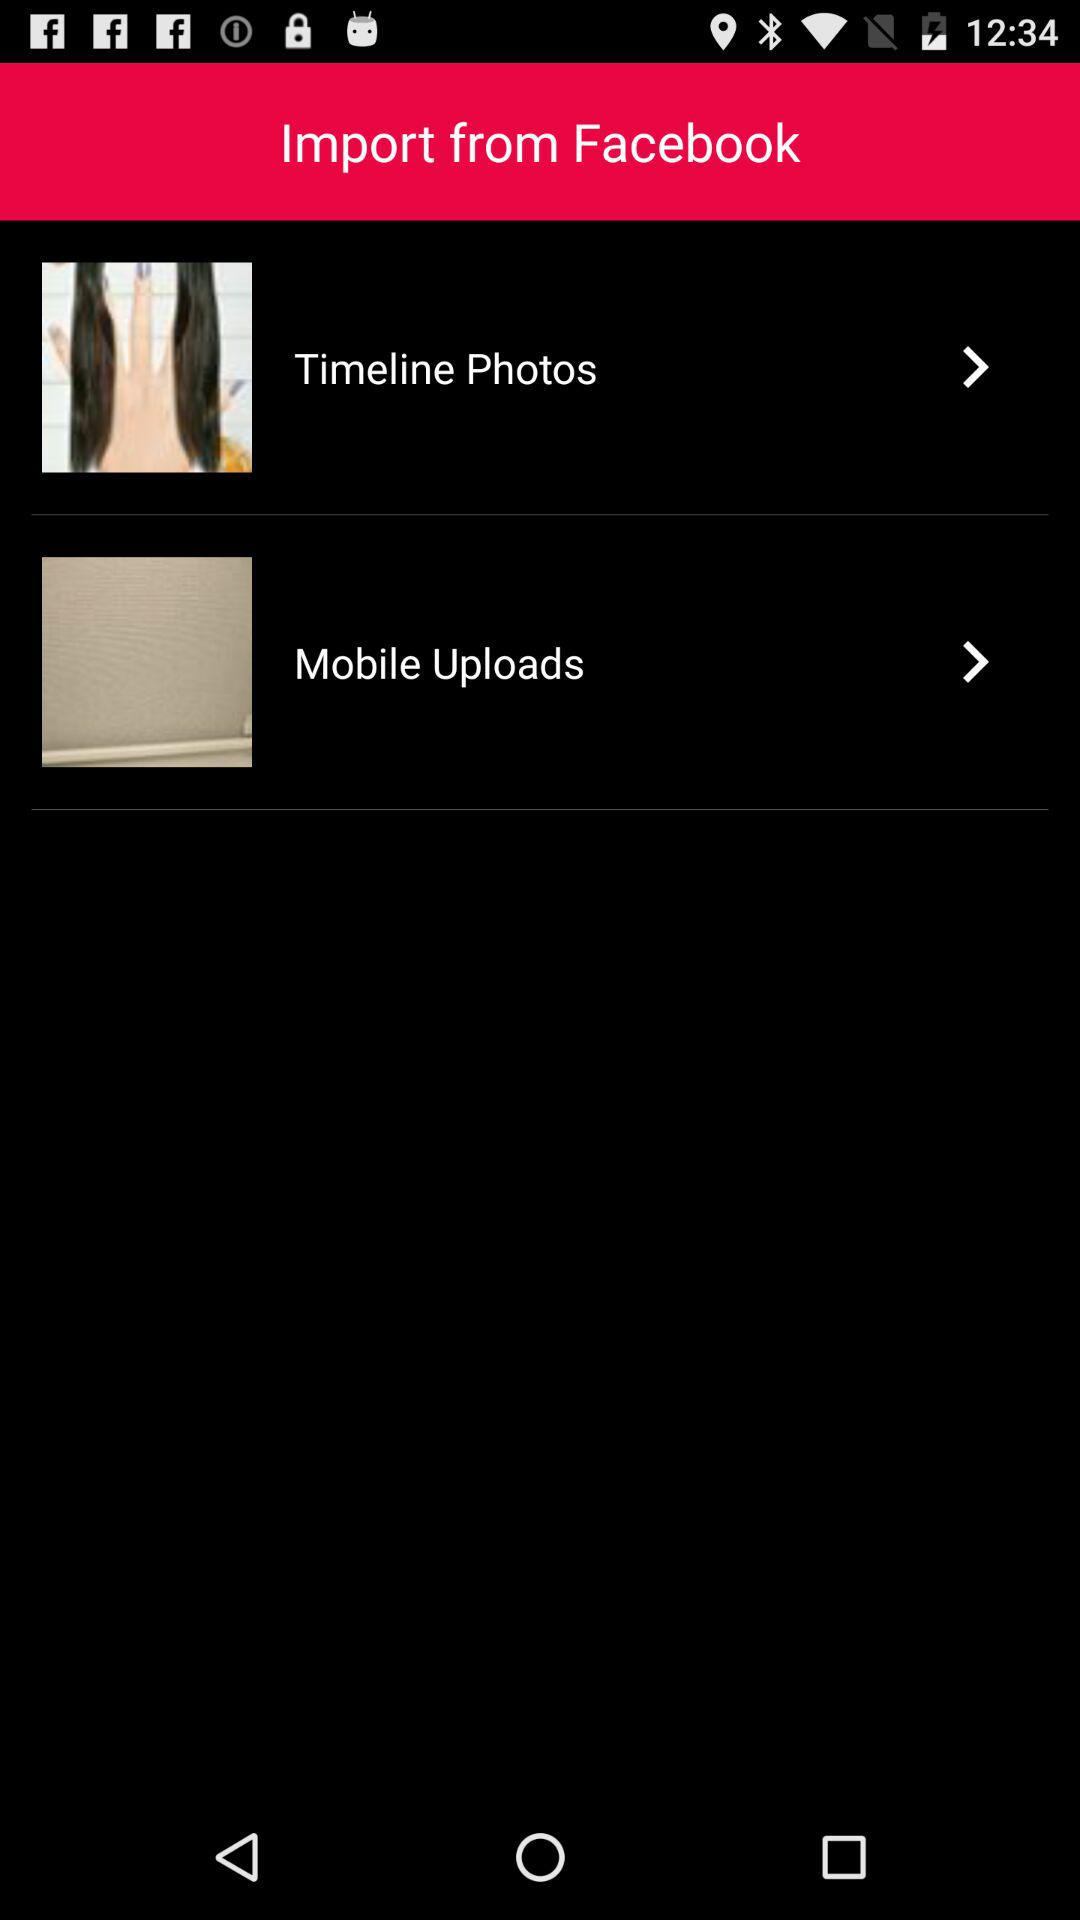From what application can the photos be imported? The photos can be imported from "Facebook". 